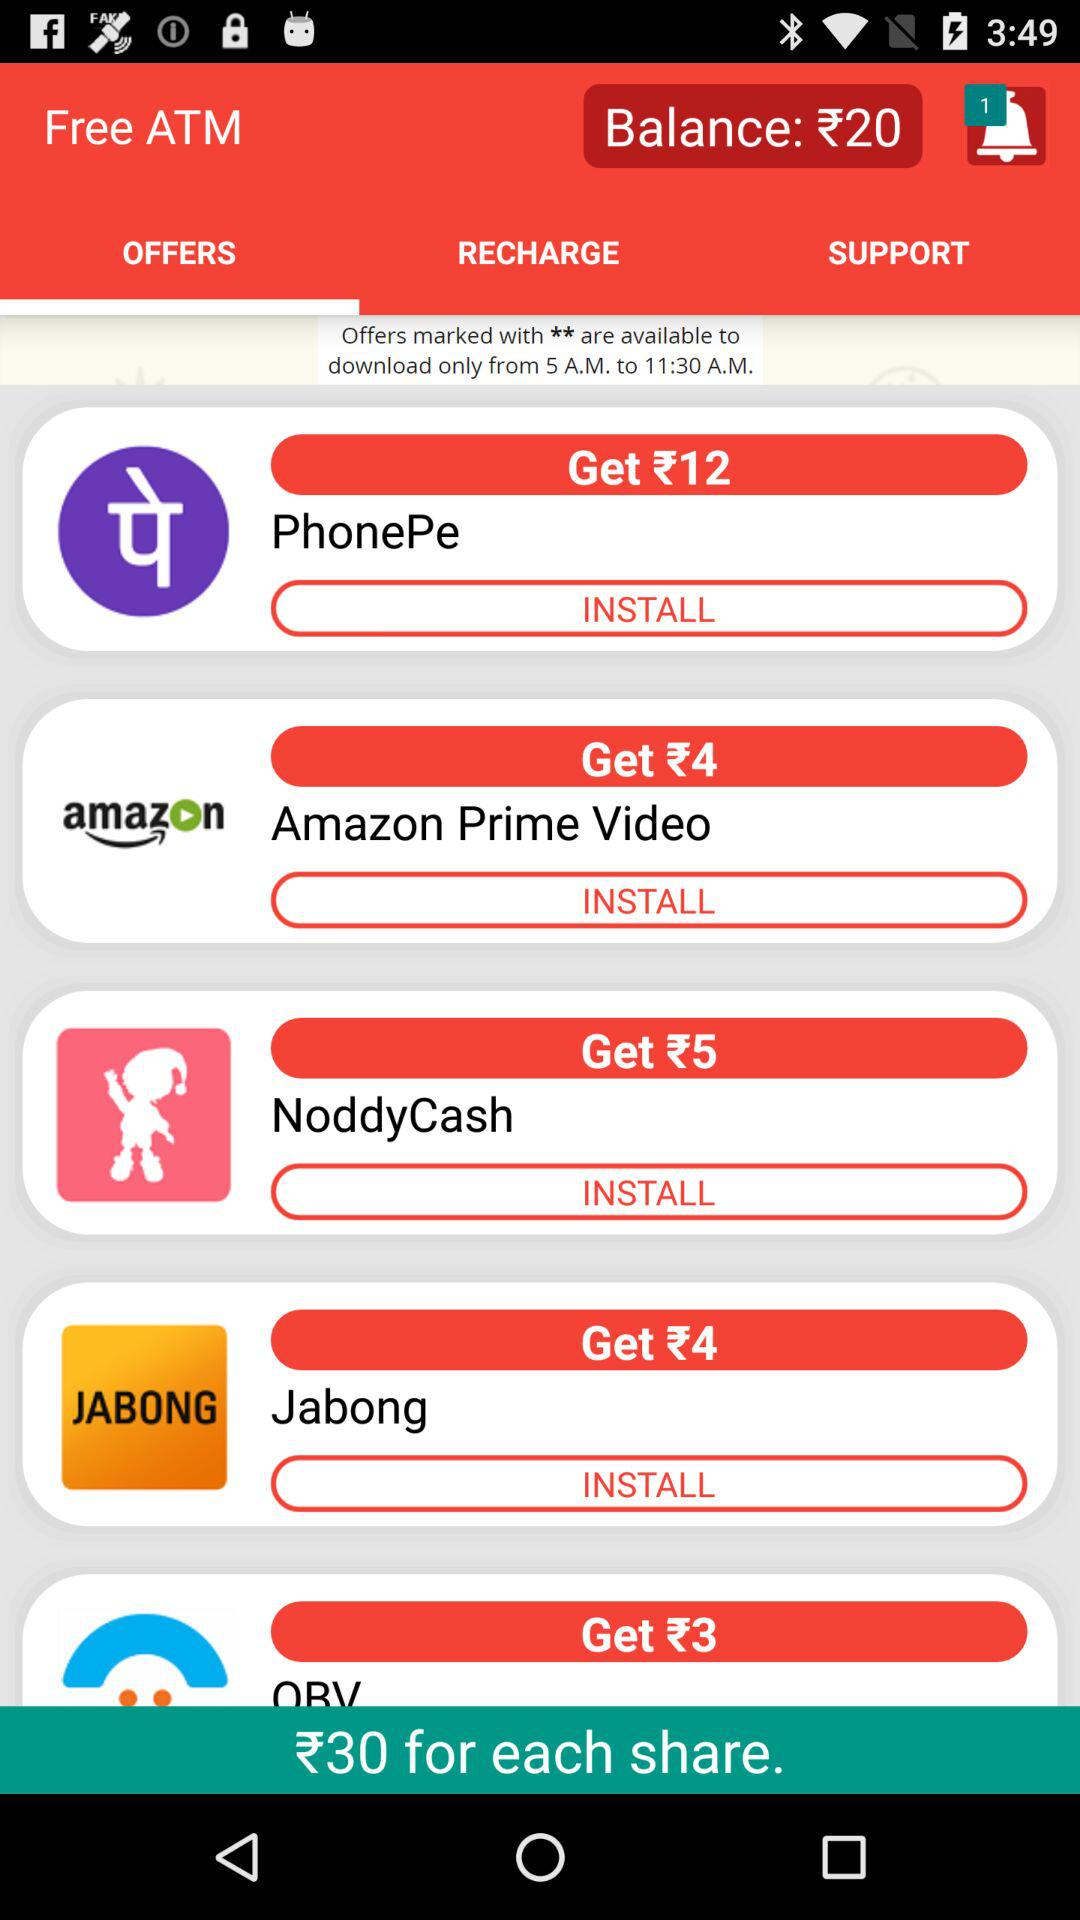How many notifications are there? There is one notification. 